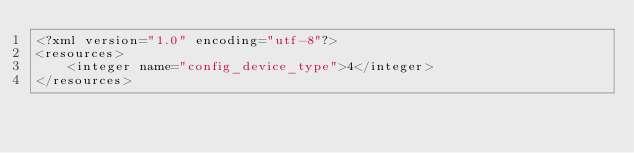<code> <loc_0><loc_0><loc_500><loc_500><_XML_><?xml version="1.0" encoding="utf-8"?>
<resources>
    <integer name="config_device_type">4</integer>
</resources></code> 